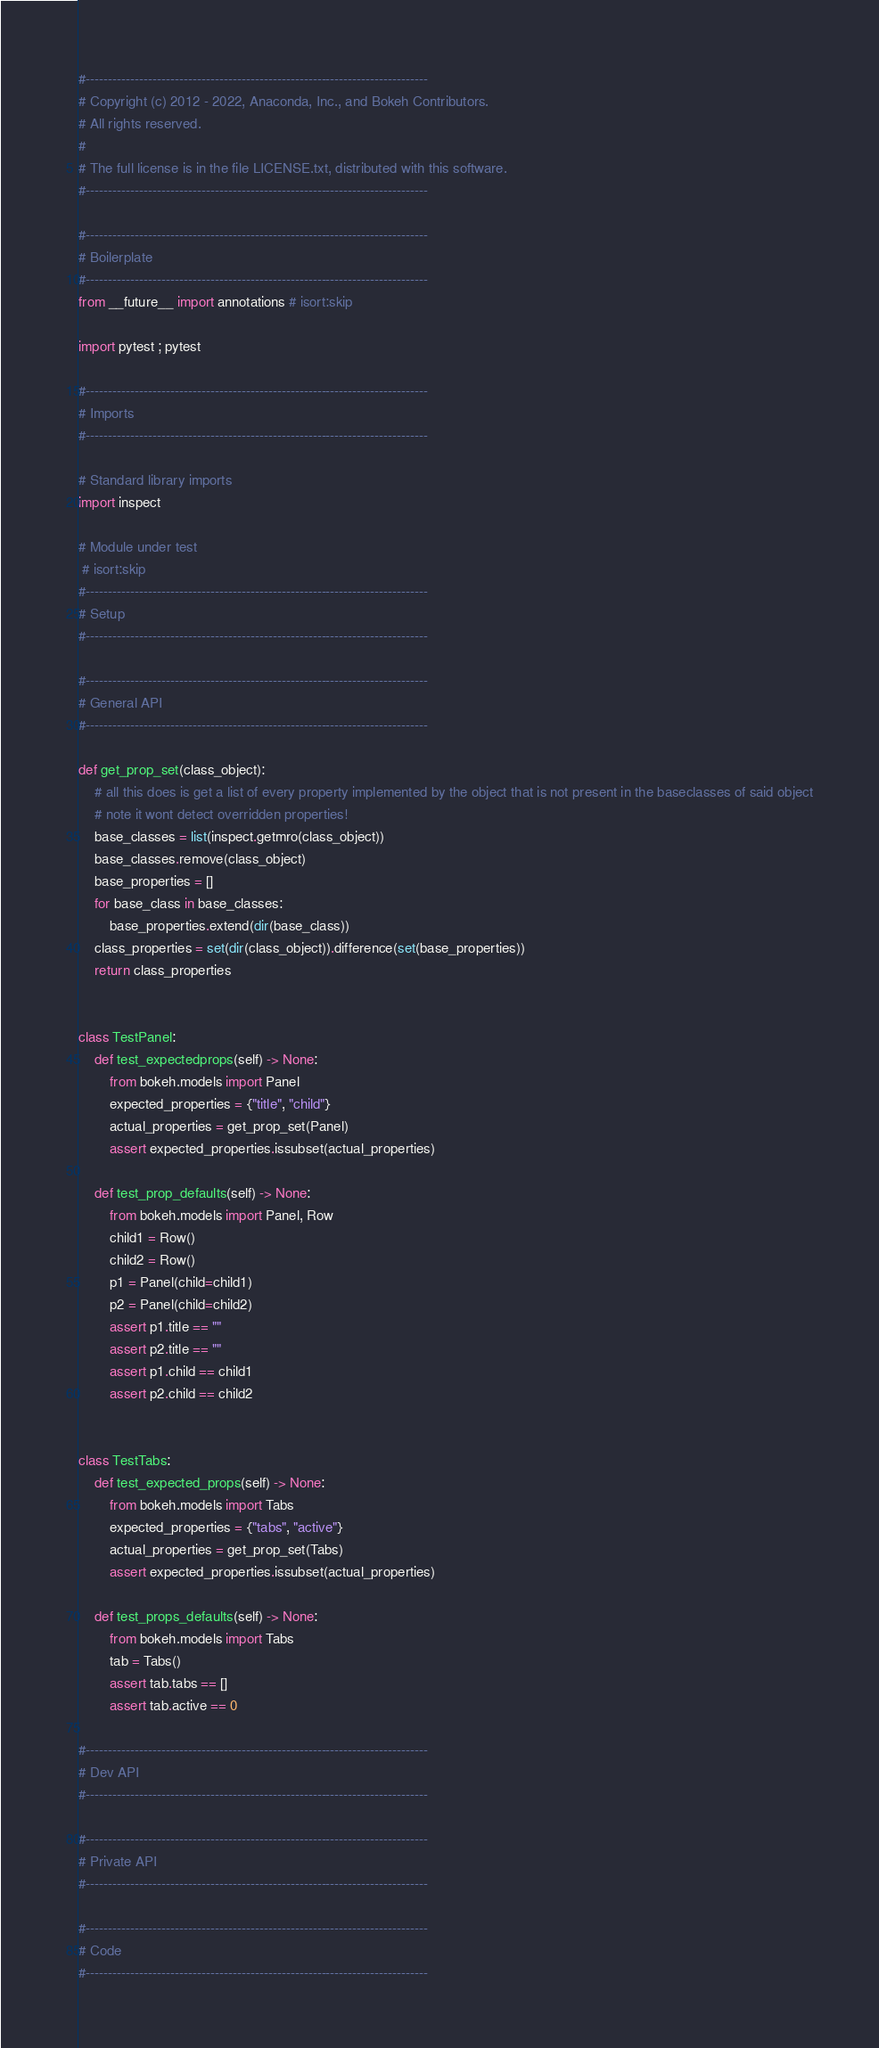<code> <loc_0><loc_0><loc_500><loc_500><_Python_>#-----------------------------------------------------------------------------
# Copyright (c) 2012 - 2022, Anaconda, Inc., and Bokeh Contributors.
# All rights reserved.
#
# The full license is in the file LICENSE.txt, distributed with this software.
#-----------------------------------------------------------------------------

#-----------------------------------------------------------------------------
# Boilerplate
#-----------------------------------------------------------------------------
from __future__ import annotations # isort:skip

import pytest ; pytest

#-----------------------------------------------------------------------------
# Imports
#-----------------------------------------------------------------------------

# Standard library imports
import inspect

# Module under test
 # isort:skip
#-----------------------------------------------------------------------------
# Setup
#-----------------------------------------------------------------------------

#-----------------------------------------------------------------------------
# General API
#-----------------------------------------------------------------------------

def get_prop_set(class_object):
    # all this does is get a list of every property implemented by the object that is not present in the baseclasses of said object
    # note it wont detect overridden properties!
    base_classes = list(inspect.getmro(class_object))
    base_classes.remove(class_object)
    base_properties = []
    for base_class in base_classes:
        base_properties.extend(dir(base_class))
    class_properties = set(dir(class_object)).difference(set(base_properties))
    return class_properties


class TestPanel:
    def test_expectedprops(self) -> None:
        from bokeh.models import Panel
        expected_properties = {"title", "child"}
        actual_properties = get_prop_set(Panel)
        assert expected_properties.issubset(actual_properties)

    def test_prop_defaults(self) -> None:
        from bokeh.models import Panel, Row
        child1 = Row()
        child2 = Row()
        p1 = Panel(child=child1)
        p2 = Panel(child=child2)
        assert p1.title == ""
        assert p2.title == ""
        assert p1.child == child1
        assert p2.child == child2


class TestTabs:
    def test_expected_props(self) -> None:
        from bokeh.models import Tabs
        expected_properties = {"tabs", "active"}
        actual_properties = get_prop_set(Tabs)
        assert expected_properties.issubset(actual_properties)

    def test_props_defaults(self) -> None:
        from bokeh.models import Tabs
        tab = Tabs()
        assert tab.tabs == []
        assert tab.active == 0

#-----------------------------------------------------------------------------
# Dev API
#-----------------------------------------------------------------------------

#-----------------------------------------------------------------------------
# Private API
#-----------------------------------------------------------------------------

#-----------------------------------------------------------------------------
# Code
#-----------------------------------------------------------------------------
</code> 